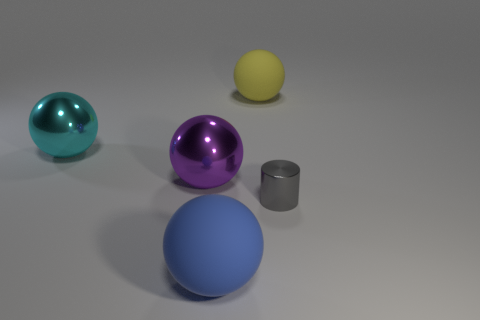Subtract 2 spheres. How many spheres are left? 2 Subtract all green balls. Subtract all cyan cubes. How many balls are left? 4 Add 3 large cyan rubber blocks. How many objects exist? 8 Subtract all spheres. How many objects are left? 1 Add 2 large cyan metallic balls. How many large cyan metallic balls are left? 3 Add 4 blue blocks. How many blue blocks exist? 4 Subtract 1 gray cylinders. How many objects are left? 4 Subtract all matte spheres. Subtract all large blue rubber things. How many objects are left? 2 